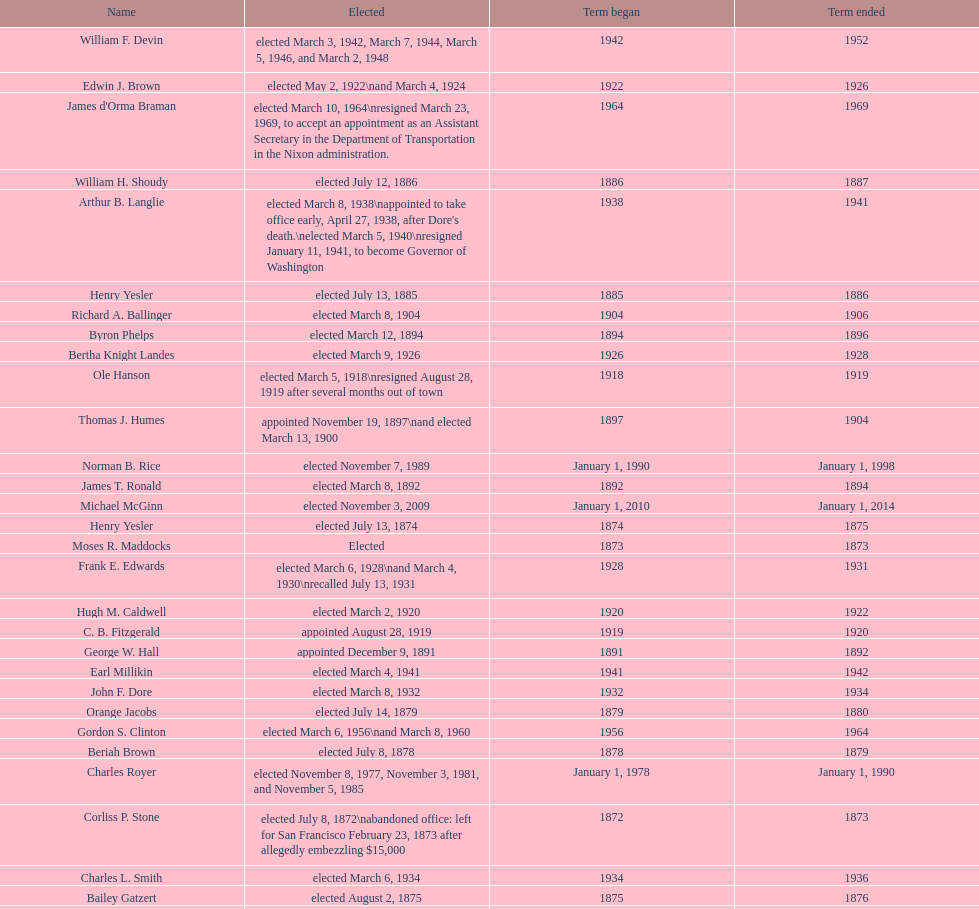Did charles royer hold office longer than paul schell? Yes. 